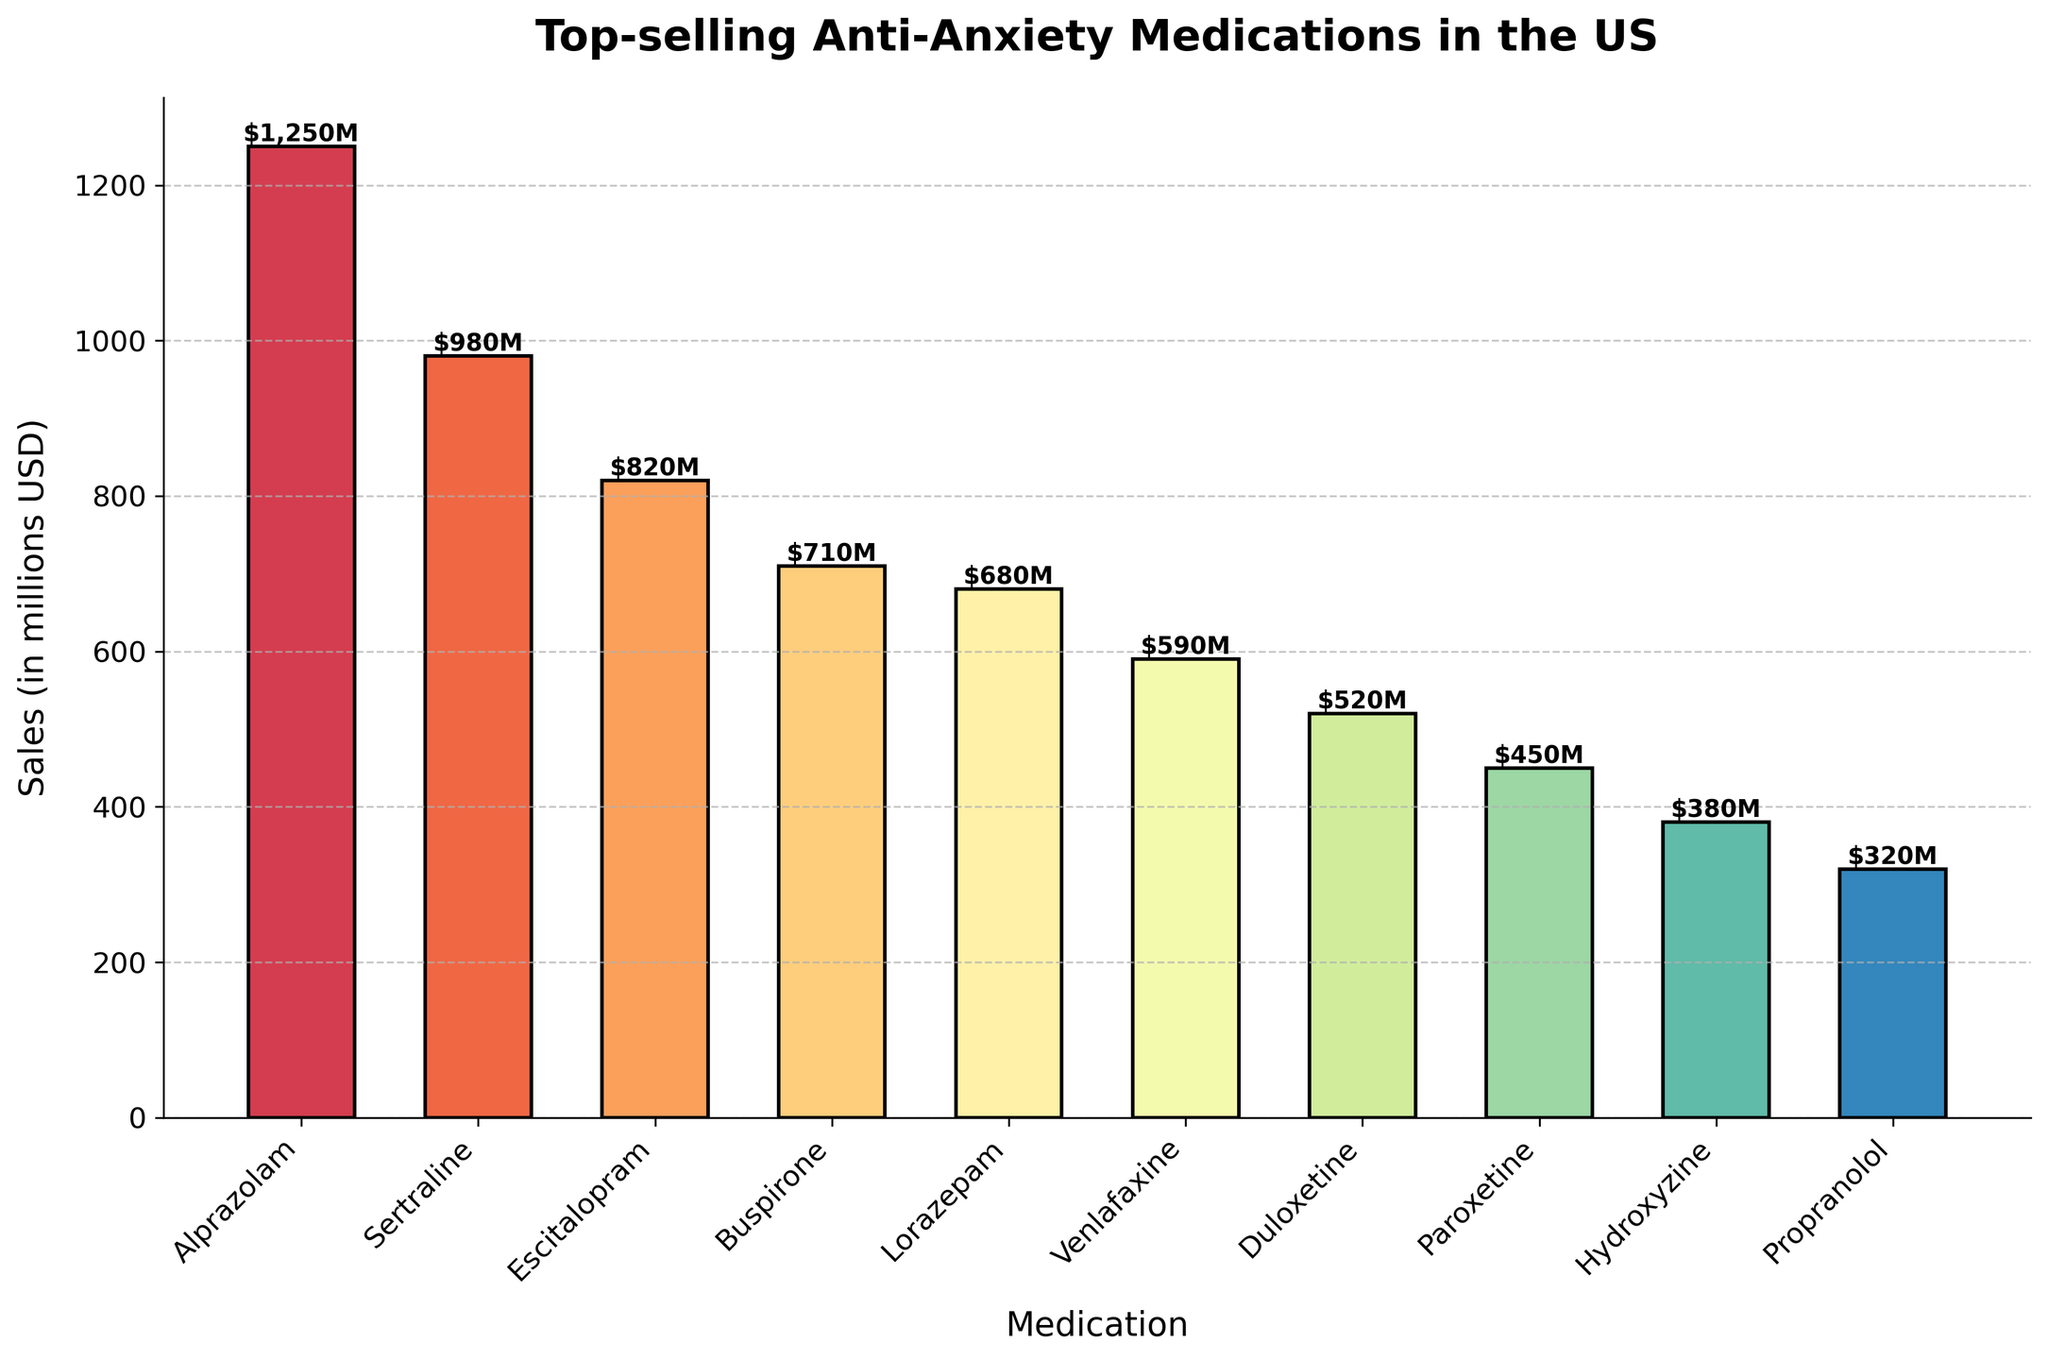What's the highest-selling medication? The highest bar on the chart represents the medication with the highest sales. The highest bar corresponds to Alprazolam, with sales of $1,250 million.
Answer: Alprazolam Which medication has the lowest sales? The shortest bar on the chart represents the medication with the lowest sales. The shortest bar corresponds to Propranolol, with sales of $320 million.
Answer: Propranolol How much more does Alprazolam sell compared to Propranolol? The sales of Alprazolam are $1,250 million, and the sales of Propranolol are $320 million. The difference is $1,250 million - $320 million = $930 million.
Answer: $930 million What is the total sales of SSRIs? The SSRIs in the chart are Sertraline with $980 million, Escitalopram with $820 million, and Paroxetine with $450 million. The total is $980 million + $820 million + $450 million = $2,250 million.
Answer: $2,250 million Which type of medication has the greatest variety in terms of different drugs listed? Counting the number of different drugs by type: Benzodiazepine has Alprazolam and Lorazepam; SSRI has Sertraline, Escitalopram, and Paroxetine; SNRI has Venlafaxine and Duloxetine; Azapirone has Buspirone; Antihistamine has Hydroxyzine; Beta-blocker has Propranolol. SSRI has the greatest variety with 3 different drugs.
Answer: SSRI What is the combined sales of Benzodiazepines? The Benzodiazepines in the chart are Alprazolam with $1,250 million and Lorazepam with $680 million. The combined sales are $1,250 million + $680 million = $1,930 million.
Answer: $1,930 million Which medication is closest in sales to $500 million? The bar closest in height to the $500 million mark represents the medication closest in sales to this figure. Duloxetine, with sales of $520 million, is the closest to $500 million.
Answer: Duloxetine Are sales of any SNRI higher than any Benzodiazepine? The highest SNRI, Venlafaxine, has sales of $590 million. The lowest Benzodiazepine, Lorazepam, has sales of $680 million. Therefore, no SNRI has sales higher than any Benzodiazepine.
Answer: No How would you rank the top three highest-selling medications? The top three highest bars represent the top three highest-selling medications. They are: 1. Alprazolam ($1,250 million) 2. Sertraline ($980 million) 3. Escitalopram ($820 million)
Answer: 1. Alprazolam, 2. Sertraline, 3. Escitalopram What is the average sales of all medications listed in the chart? Sum all the sales figures and divide by the number of medications. Total sales = $1,250 million + $980 million + $820 million + $710 million + $680 million + $590 million + $520 million + $450 million + $380 million + $320 million = $6,700 million. Number of medications = 10. Average sales = $6,700 million / 10 = $670 million.
Answer: $670 million 